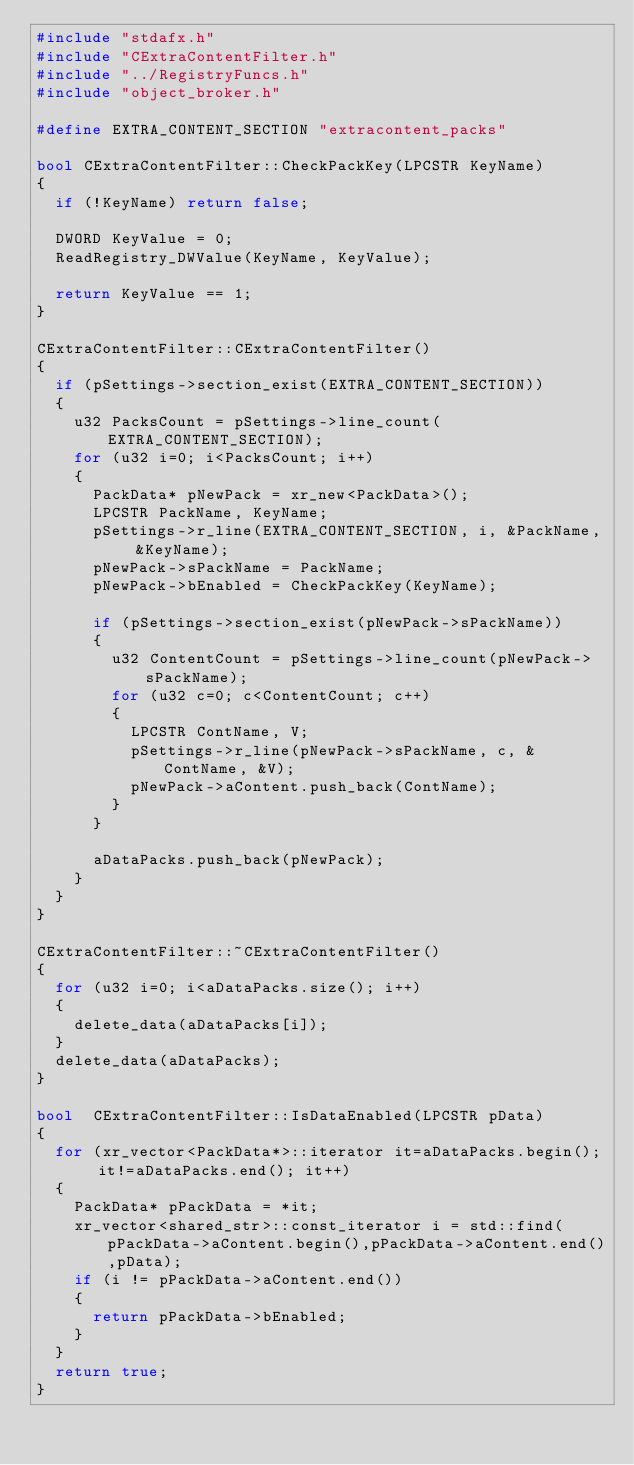Convert code to text. <code><loc_0><loc_0><loc_500><loc_500><_C++_>#include "stdafx.h"
#include "CExtraContentFilter.h"
#include "../RegistryFuncs.h"
#include "object_broker.h"

#define EXTRA_CONTENT_SECTION	"extracontent_packs"	

bool CExtraContentFilter::CheckPackKey(LPCSTR KeyName)
{
	if (!KeyName) return false;

	DWORD KeyValue = 0;
	ReadRegistry_DWValue(KeyName, KeyValue);

	return KeyValue == 1;
}

CExtraContentFilter::CExtraContentFilter()
{
	if (pSettings->section_exist(EXTRA_CONTENT_SECTION))
	{
		u32 PacksCount = pSettings->line_count(EXTRA_CONTENT_SECTION);
		for (u32 i=0; i<PacksCount; i++)
		{
			PackData* pNewPack = xr_new<PackData>();
			LPCSTR PackName, KeyName;
			pSettings->r_line(EXTRA_CONTENT_SECTION, i, &PackName, &KeyName);
			pNewPack->sPackName = PackName;
			pNewPack->bEnabled = CheckPackKey(KeyName);

			if (pSettings->section_exist(pNewPack->sPackName))
			{
				u32 ContentCount = pSettings->line_count(pNewPack->sPackName);
				for (u32 c=0; c<ContentCount; c++)
				{
					LPCSTR ContName, V;
					pSettings->r_line(pNewPack->sPackName, c, &ContName, &V);
					pNewPack->aContent.push_back(ContName);
				}
			}

			aDataPacks.push_back(pNewPack);
		}
	}
}

CExtraContentFilter::~CExtraContentFilter()
{
	for (u32 i=0; i<aDataPacks.size(); i++)
	{
		delete_data(aDataPacks[i]);
	}
	delete_data(aDataPacks);
}

bool	CExtraContentFilter::IsDataEnabled(LPCSTR pData)
{
	for (xr_vector<PackData*>::iterator it=aDataPacks.begin(); it!=aDataPacks.end(); it++)
	{
		PackData* pPackData = *it;
		xr_vector<shared_str>::const_iterator	i = std::find(pPackData->aContent.begin(),pPackData->aContent.end(),pData);
		if (i != pPackData->aContent.end())
		{
			return pPackData->bEnabled;
		}
	}
	return true;
}</code> 